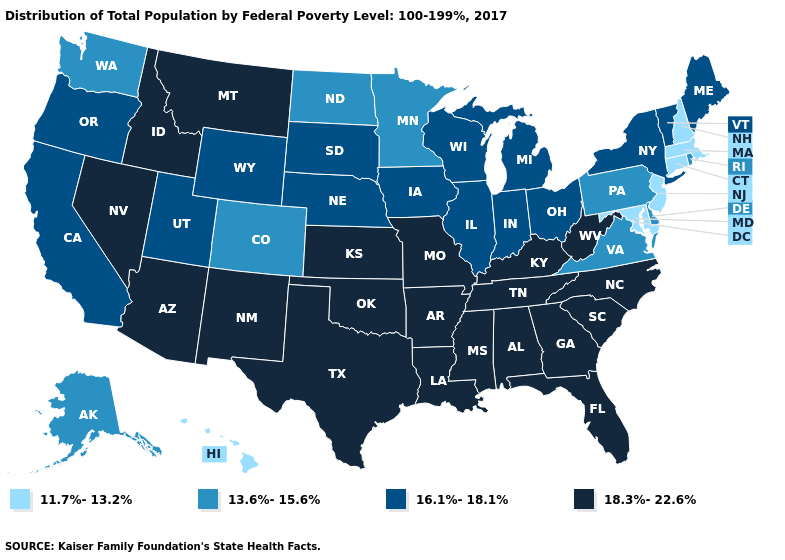What is the lowest value in the Northeast?
Keep it brief. 11.7%-13.2%. Does Nevada have a higher value than Florida?
Quick response, please. No. What is the value of Wisconsin?
Concise answer only. 16.1%-18.1%. Name the states that have a value in the range 18.3%-22.6%?
Keep it brief. Alabama, Arizona, Arkansas, Florida, Georgia, Idaho, Kansas, Kentucky, Louisiana, Mississippi, Missouri, Montana, Nevada, New Mexico, North Carolina, Oklahoma, South Carolina, Tennessee, Texas, West Virginia. Name the states that have a value in the range 11.7%-13.2%?
Write a very short answer. Connecticut, Hawaii, Maryland, Massachusetts, New Hampshire, New Jersey. What is the value of Iowa?
Short answer required. 16.1%-18.1%. Name the states that have a value in the range 13.6%-15.6%?
Write a very short answer. Alaska, Colorado, Delaware, Minnesota, North Dakota, Pennsylvania, Rhode Island, Virginia, Washington. What is the value of Montana?
Answer briefly. 18.3%-22.6%. Does the map have missing data?
Short answer required. No. Does Virginia have a higher value than New Jersey?
Answer briefly. Yes. Does the first symbol in the legend represent the smallest category?
Keep it brief. Yes. What is the lowest value in the MidWest?
Short answer required. 13.6%-15.6%. Name the states that have a value in the range 18.3%-22.6%?
Quick response, please. Alabama, Arizona, Arkansas, Florida, Georgia, Idaho, Kansas, Kentucky, Louisiana, Mississippi, Missouri, Montana, Nevada, New Mexico, North Carolina, Oklahoma, South Carolina, Tennessee, Texas, West Virginia. What is the value of Louisiana?
Keep it brief. 18.3%-22.6%. What is the value of West Virginia?
Answer briefly. 18.3%-22.6%. 